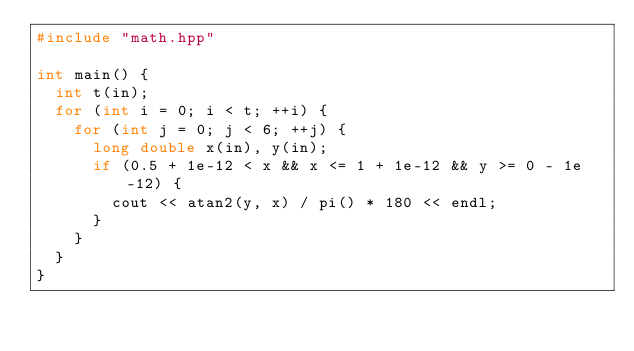Convert code to text. <code><loc_0><loc_0><loc_500><loc_500><_C++_>#include "math.hpp"

int main() {
  int t(in);
  for (int i = 0; i < t; ++i) {
    for (int j = 0; j < 6; ++j) {
      long double x(in), y(in);
      if (0.5 + 1e-12 < x && x <= 1 + 1e-12 && y >= 0 - 1e-12) {
        cout << atan2(y, x) / pi() * 180 << endl;
      }
    }
  }
}
</code> 